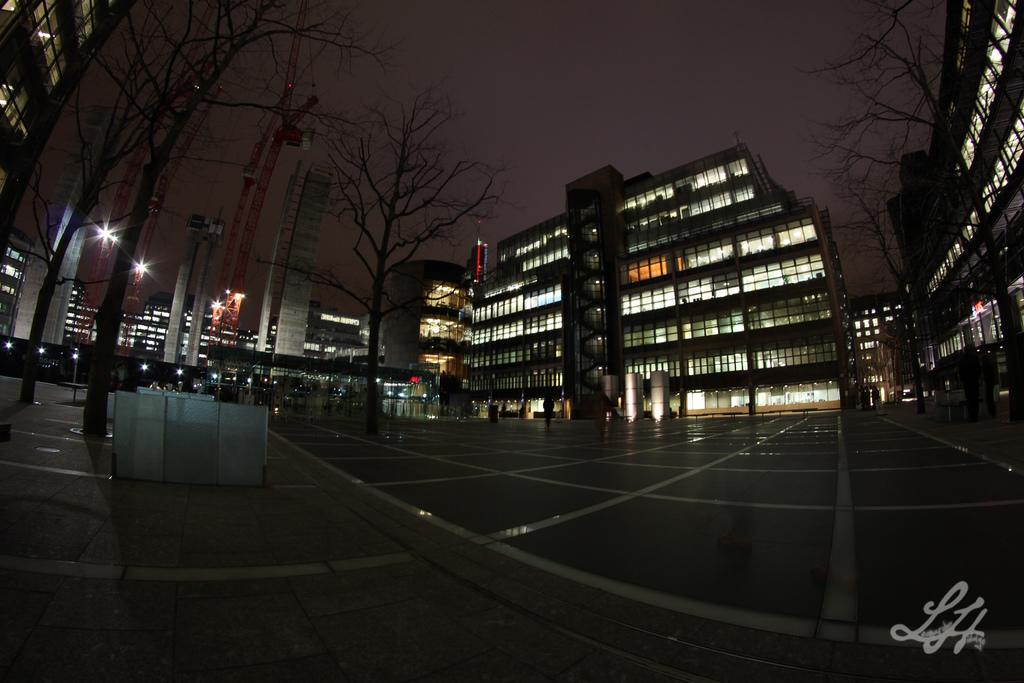What type of natural elements can be seen in the image? There are trees in the image. What type of man-made structures can be seen in the background of the image? There are buildings in the background of the image. What part of the natural environment is visible in the image? The sky is visible in the background of the image. How many dolls are exchanging houses in the image? There are no dolls or houses present in the image, so this scenario cannot be observed. 